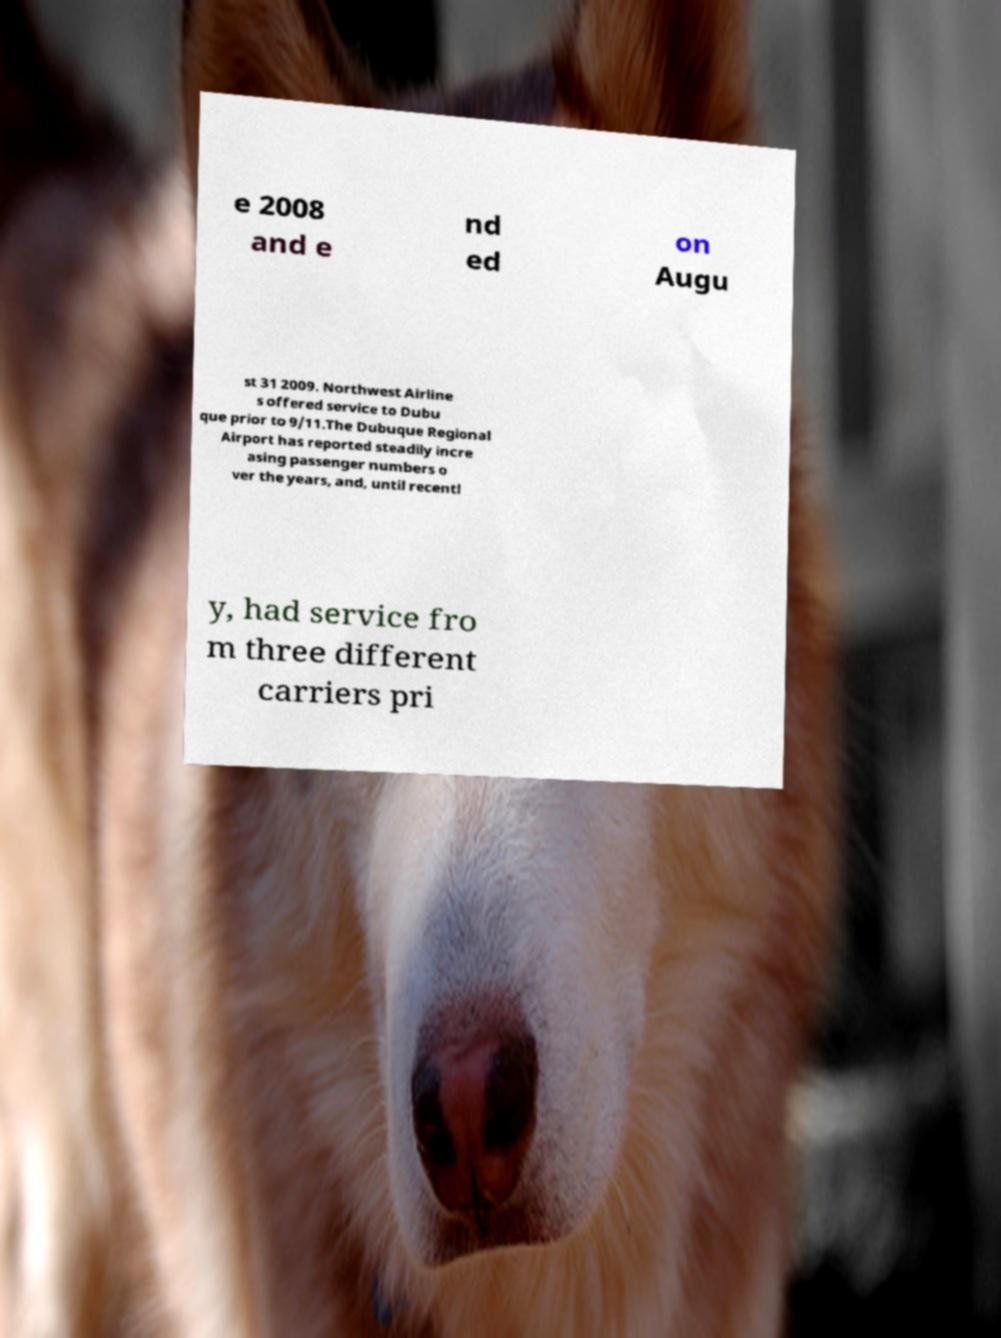Can you accurately transcribe the text from the provided image for me? e 2008 and e nd ed on Augu st 31 2009. Northwest Airline s offered service to Dubu que prior to 9/11.The Dubuque Regional Airport has reported steadily incre asing passenger numbers o ver the years, and, until recentl y, had service fro m three different carriers pri 